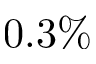Convert formula to latex. <formula><loc_0><loc_0><loc_500><loc_500>0 . 3 \%</formula> 